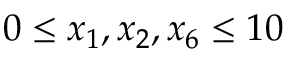Convert formula to latex. <formula><loc_0><loc_0><loc_500><loc_500>0 \leq x _ { 1 } , x _ { 2 } , x _ { 6 } \leq 1 0</formula> 